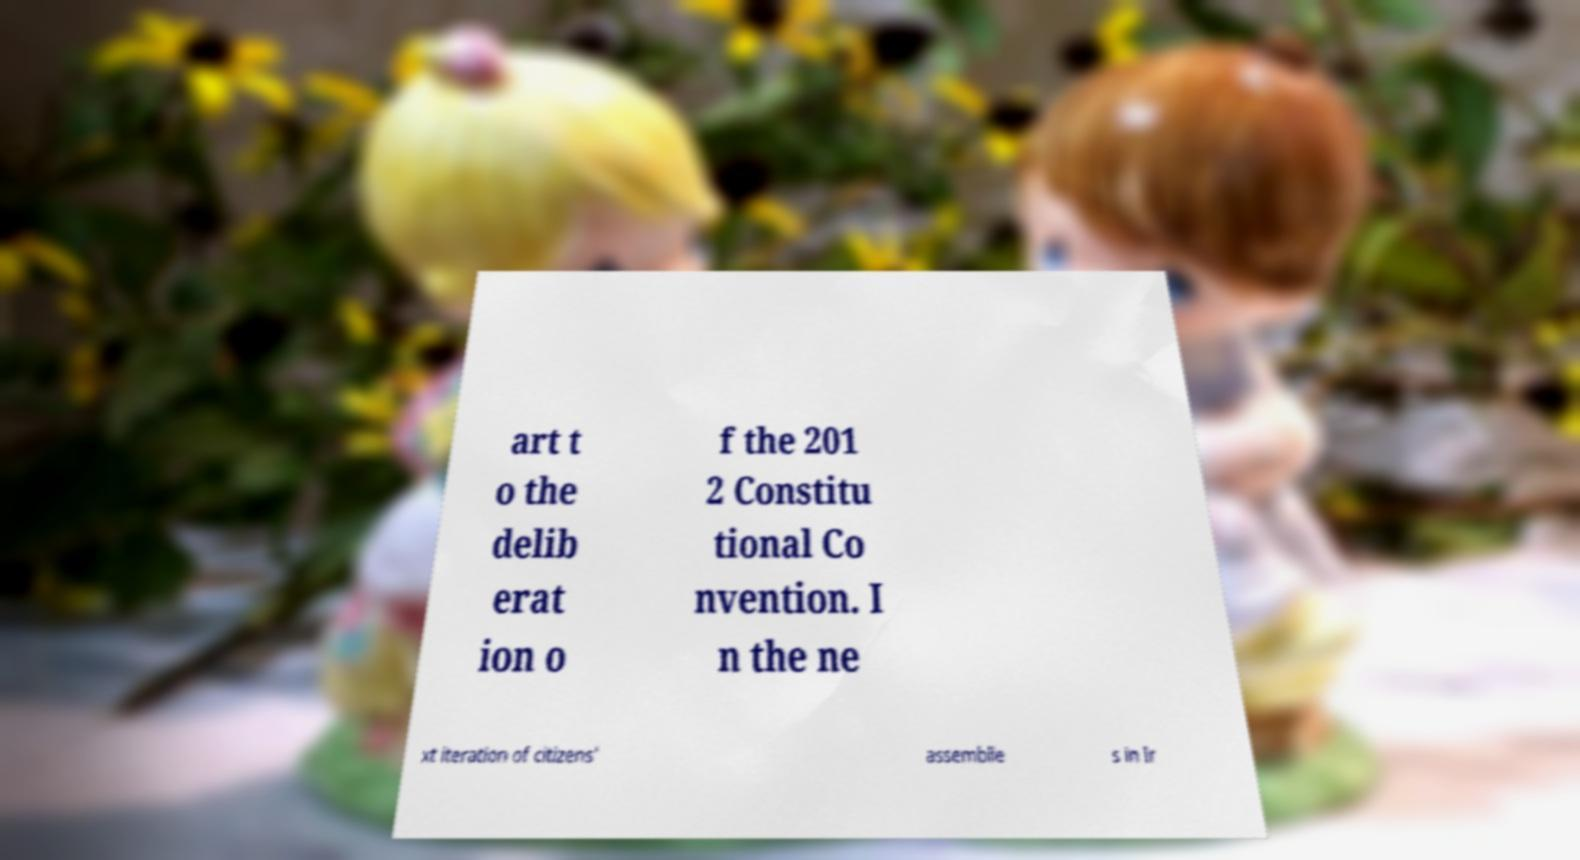What messages or text are displayed in this image? I need them in a readable, typed format. art t o the delib erat ion o f the 201 2 Constitu tional Co nvention. I n the ne xt iteration of citizens' assemblie s in Ir 